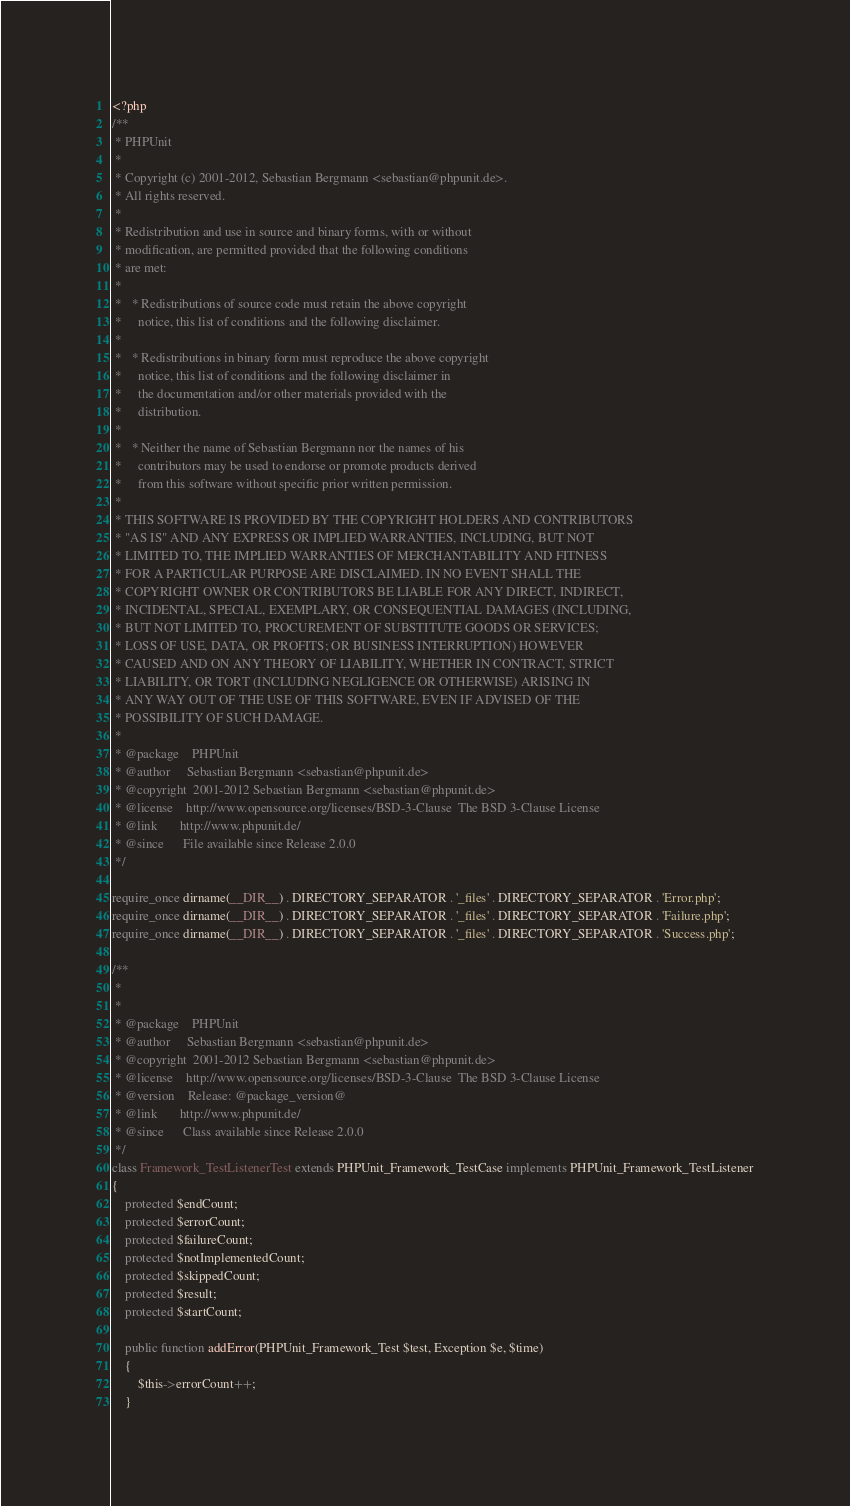Convert code to text. <code><loc_0><loc_0><loc_500><loc_500><_PHP_><?php
/**
 * PHPUnit
 *
 * Copyright (c) 2001-2012, Sebastian Bergmann <sebastian@phpunit.de>.
 * All rights reserved.
 *
 * Redistribution and use in source and binary forms, with or without
 * modification, are permitted provided that the following conditions
 * are met:
 *
 *   * Redistributions of source code must retain the above copyright
 *     notice, this list of conditions and the following disclaimer.
 *
 *   * Redistributions in binary form must reproduce the above copyright
 *     notice, this list of conditions and the following disclaimer in
 *     the documentation and/or other materials provided with the
 *     distribution.
 *
 *   * Neither the name of Sebastian Bergmann nor the names of his
 *     contributors may be used to endorse or promote products derived
 *     from this software without specific prior written permission.
 *
 * THIS SOFTWARE IS PROVIDED BY THE COPYRIGHT HOLDERS AND CONTRIBUTORS
 * "AS IS" AND ANY EXPRESS OR IMPLIED WARRANTIES, INCLUDING, BUT NOT
 * LIMITED TO, THE IMPLIED WARRANTIES OF MERCHANTABILITY AND FITNESS
 * FOR A PARTICULAR PURPOSE ARE DISCLAIMED. IN NO EVENT SHALL THE
 * COPYRIGHT OWNER OR CONTRIBUTORS BE LIABLE FOR ANY DIRECT, INDIRECT,
 * INCIDENTAL, SPECIAL, EXEMPLARY, OR CONSEQUENTIAL DAMAGES (INCLUDING,
 * BUT NOT LIMITED TO, PROCUREMENT OF SUBSTITUTE GOODS OR SERVICES;
 * LOSS OF USE, DATA, OR PROFITS; OR BUSINESS INTERRUPTION) HOWEVER
 * CAUSED AND ON ANY THEORY OF LIABILITY, WHETHER IN CONTRACT, STRICT
 * LIABILITY, OR TORT (INCLUDING NEGLIGENCE OR OTHERWISE) ARISING IN
 * ANY WAY OUT OF THE USE OF THIS SOFTWARE, EVEN IF ADVISED OF THE
 * POSSIBILITY OF SUCH DAMAGE.
 *
 * @package    PHPUnit
 * @author     Sebastian Bergmann <sebastian@phpunit.de>
 * @copyright  2001-2012 Sebastian Bergmann <sebastian@phpunit.de>
 * @license    http://www.opensource.org/licenses/BSD-3-Clause  The BSD 3-Clause License
 * @link       http://www.phpunit.de/
 * @since      File available since Release 2.0.0
 */

require_once dirname(__DIR__) . DIRECTORY_SEPARATOR . '_files' . DIRECTORY_SEPARATOR . 'Error.php';
require_once dirname(__DIR__) . DIRECTORY_SEPARATOR . '_files' . DIRECTORY_SEPARATOR . 'Failure.php';
require_once dirname(__DIR__) . DIRECTORY_SEPARATOR . '_files' . DIRECTORY_SEPARATOR . 'Success.php';

/**
 *
 *
 * @package    PHPUnit
 * @author     Sebastian Bergmann <sebastian@phpunit.de>
 * @copyright  2001-2012 Sebastian Bergmann <sebastian@phpunit.de>
 * @license    http://www.opensource.org/licenses/BSD-3-Clause  The BSD 3-Clause License
 * @version    Release: @package_version@
 * @link       http://www.phpunit.de/
 * @since      Class available since Release 2.0.0
 */
class Framework_TestListenerTest extends PHPUnit_Framework_TestCase implements PHPUnit_Framework_TestListener
{
    protected $endCount;
    protected $errorCount;
    protected $failureCount;
    protected $notImplementedCount;
    protected $skippedCount;
    protected $result;
    protected $startCount;

    public function addError(PHPUnit_Framework_Test $test, Exception $e, $time)
    {
        $this->errorCount++;
    }
</code> 